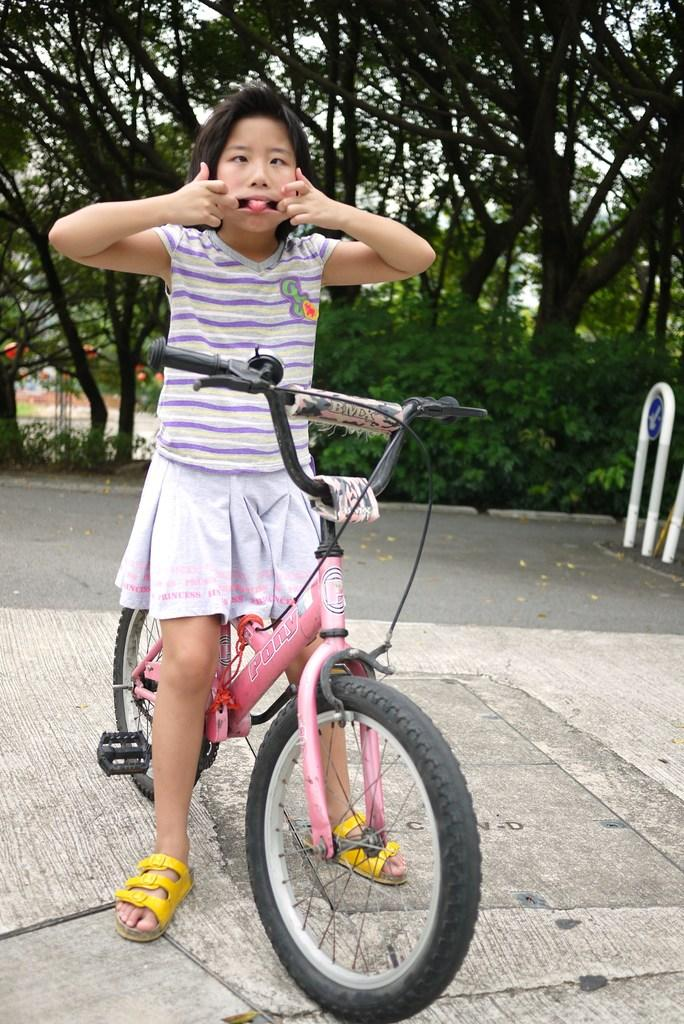Who is the main subject in the image? There is a girl in the image. What is the girl doing in the image? The girl is standing next to a bicycle and pulling her mouth open with her hands. Where is the girl located in the image? The girl is on a road. What can be seen in the background of the image? There are trees visible in the background of the image. What type of paint is the girl using on the actor in the image? There is no actor or paint present in the image; it features a girl standing next to a bicycle on a road. 